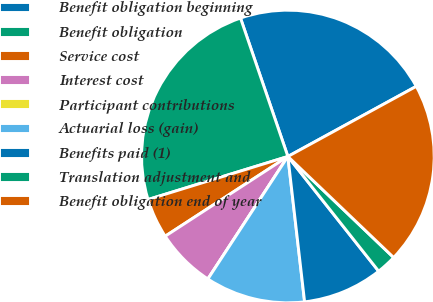Convert chart to OTSL. <chart><loc_0><loc_0><loc_500><loc_500><pie_chart><fcel>Benefit obligation beginning<fcel>Benefit obligation<fcel>Service cost<fcel>Interest cost<fcel>Participant contributions<fcel>Actuarial loss (gain)<fcel>Benefits paid (1)<fcel>Translation adjustment and<fcel>Benefit obligation end of year<nl><fcel>22.29%<fcel>24.5%<fcel>4.42%<fcel>6.62%<fcel>0.0%<fcel>11.03%<fcel>8.83%<fcel>2.21%<fcel>20.09%<nl></chart> 